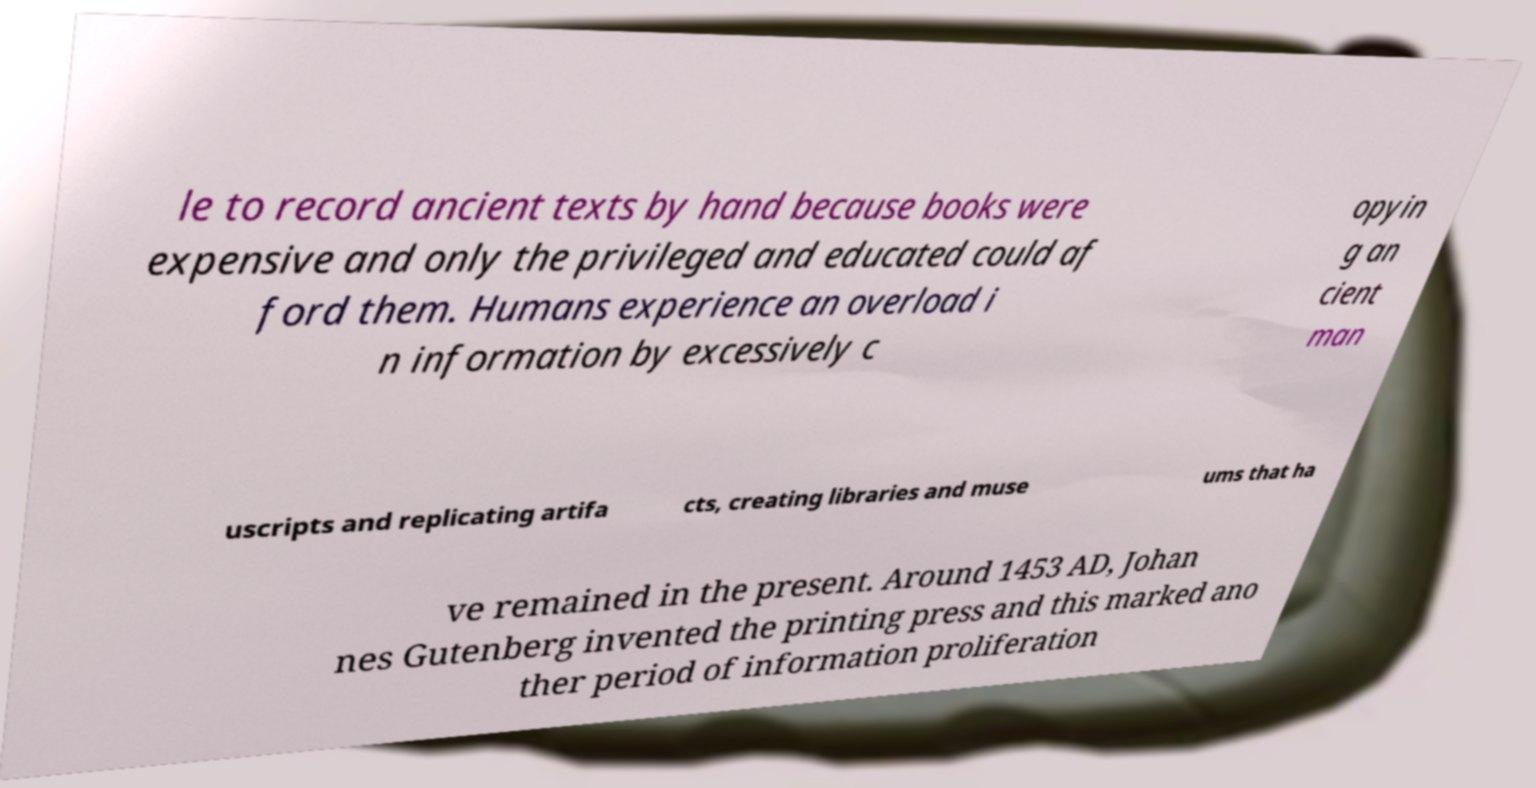Can you accurately transcribe the text from the provided image for me? le to record ancient texts by hand because books were expensive and only the privileged and educated could af ford them. Humans experience an overload i n information by excessively c opyin g an cient man uscripts and replicating artifa cts, creating libraries and muse ums that ha ve remained in the present. Around 1453 AD, Johan nes Gutenberg invented the printing press and this marked ano ther period of information proliferation 